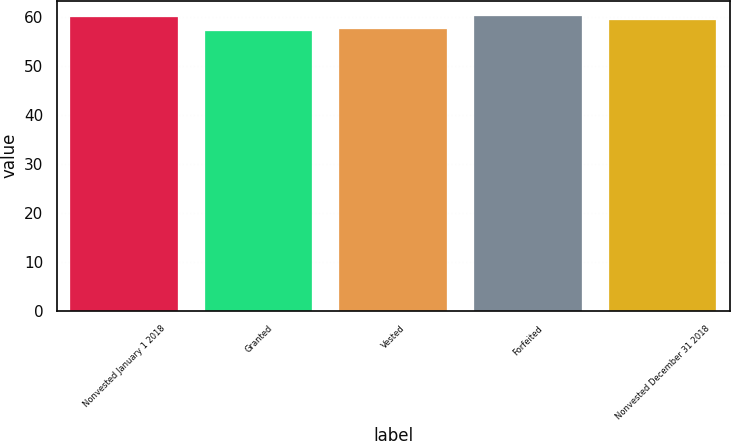Convert chart to OTSL. <chart><loc_0><loc_0><loc_500><loc_500><bar_chart><fcel>Nonvested January 1 2018<fcel>Granted<fcel>Vested<fcel>Forfeited<fcel>Nonvested December 31 2018<nl><fcel>60.03<fcel>57.17<fcel>57.59<fcel>60.32<fcel>59.42<nl></chart> 